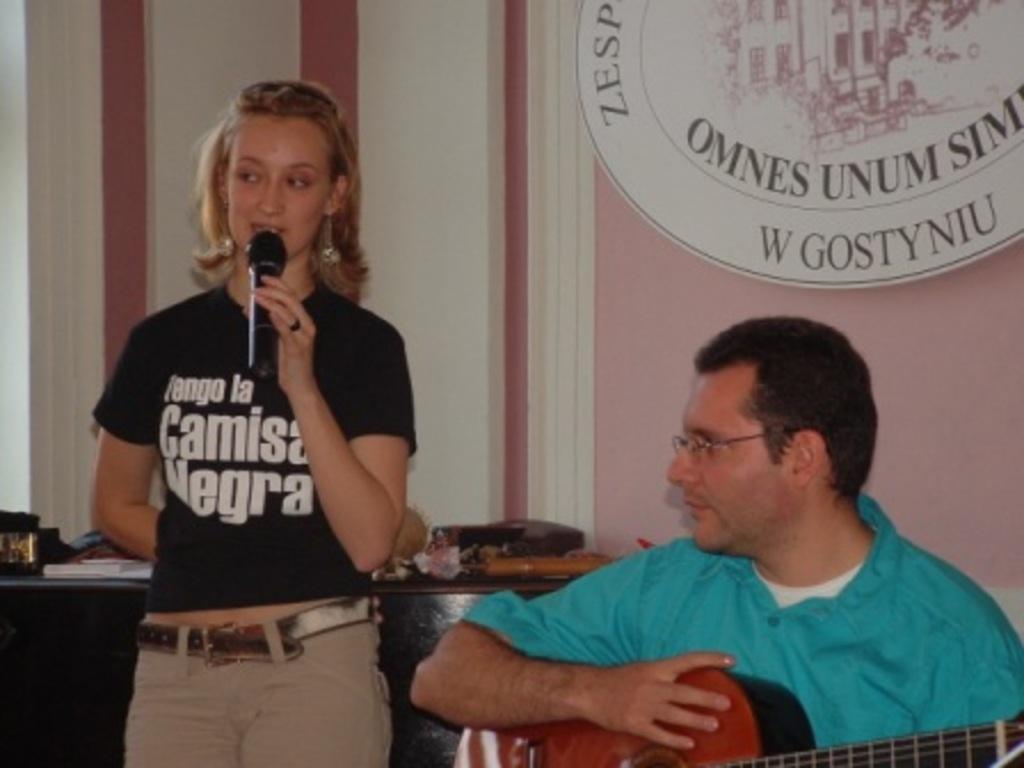Describe this image in one or two sentences. In this image i can see a woman is standing and holding a microphone and a man sitting and holding a guitar in his hand. 